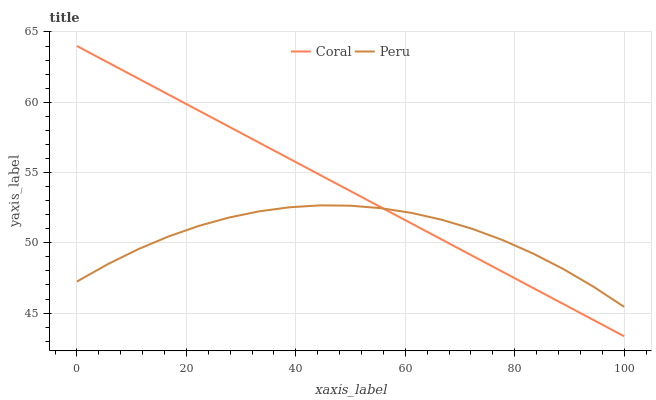Does Peru have the minimum area under the curve?
Answer yes or no. Yes. Does Coral have the maximum area under the curve?
Answer yes or no. Yes. Does Peru have the maximum area under the curve?
Answer yes or no. No. Is Coral the smoothest?
Answer yes or no. Yes. Is Peru the roughest?
Answer yes or no. Yes. Is Peru the smoothest?
Answer yes or no. No. Does Coral have the lowest value?
Answer yes or no. Yes. Does Peru have the lowest value?
Answer yes or no. No. Does Coral have the highest value?
Answer yes or no. Yes. Does Peru have the highest value?
Answer yes or no. No. Does Peru intersect Coral?
Answer yes or no. Yes. Is Peru less than Coral?
Answer yes or no. No. Is Peru greater than Coral?
Answer yes or no. No. 